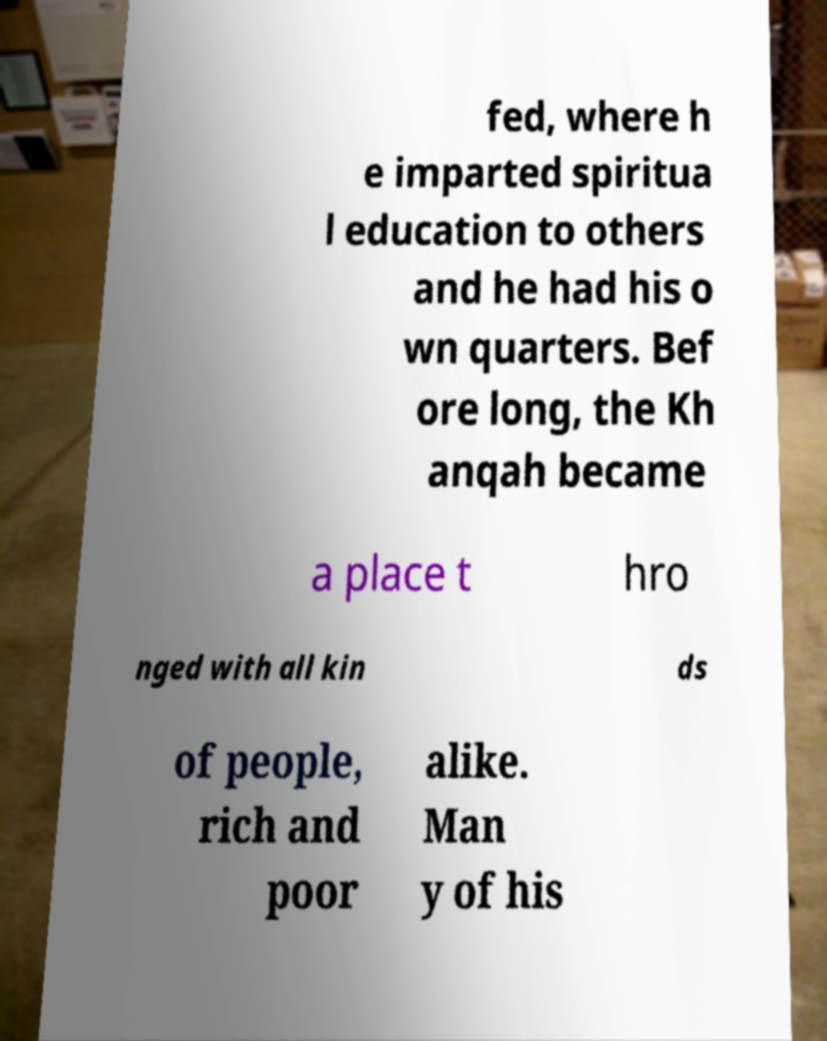Please read and relay the text visible in this image. What does it say? fed, where h e imparted spiritua l education to others and he had his o wn quarters. Bef ore long, the Kh anqah became a place t hro nged with all kin ds of people, rich and poor alike. Man y of his 